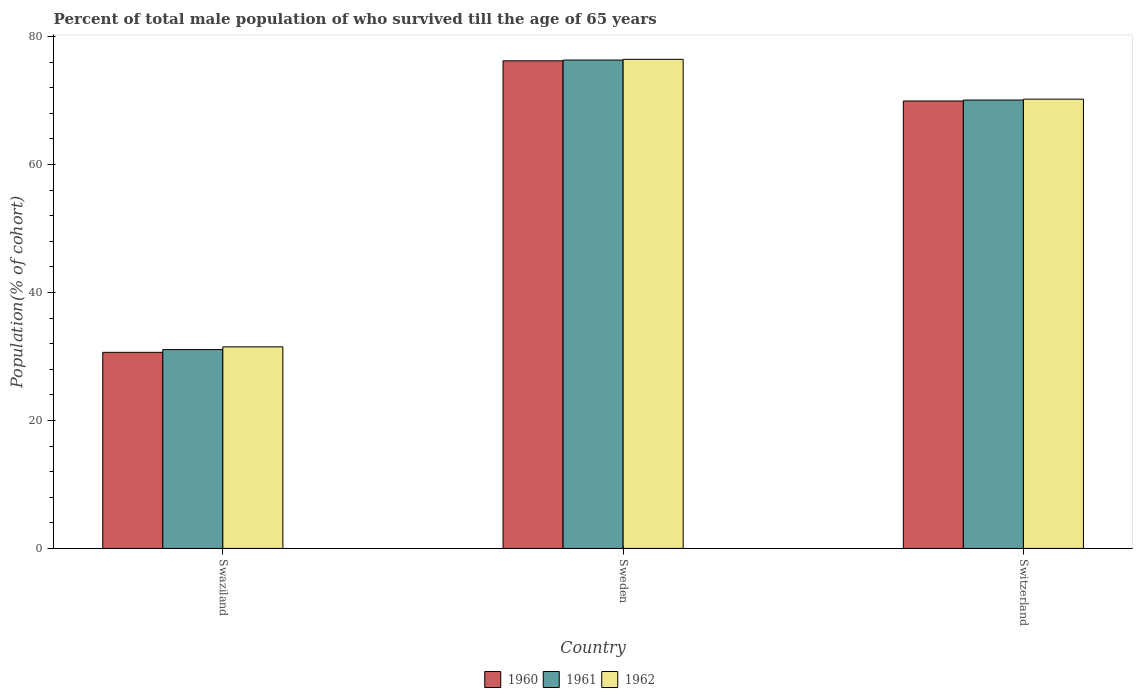How many groups of bars are there?
Your response must be concise. 3. Are the number of bars per tick equal to the number of legend labels?
Offer a terse response. Yes. What is the label of the 1st group of bars from the left?
Provide a short and direct response. Swaziland. What is the percentage of total male population who survived till the age of 65 years in 1961 in Swaziland?
Your response must be concise. 31.08. Across all countries, what is the maximum percentage of total male population who survived till the age of 65 years in 1961?
Offer a very short reply. 76.33. Across all countries, what is the minimum percentage of total male population who survived till the age of 65 years in 1961?
Offer a terse response. 31.08. In which country was the percentage of total male population who survived till the age of 65 years in 1962 minimum?
Make the answer very short. Swaziland. What is the total percentage of total male population who survived till the age of 65 years in 1960 in the graph?
Your answer should be very brief. 176.81. What is the difference between the percentage of total male population who survived till the age of 65 years in 1960 in Swaziland and that in Sweden?
Offer a very short reply. -45.56. What is the difference between the percentage of total male population who survived till the age of 65 years in 1960 in Switzerland and the percentage of total male population who survived till the age of 65 years in 1961 in Swaziland?
Your answer should be very brief. 38.86. What is the average percentage of total male population who survived till the age of 65 years in 1961 per country?
Offer a very short reply. 59.16. What is the difference between the percentage of total male population who survived till the age of 65 years of/in 1962 and percentage of total male population who survived till the age of 65 years of/in 1960 in Switzerland?
Give a very brief answer. 0.29. What is the ratio of the percentage of total male population who survived till the age of 65 years in 1960 in Swaziland to that in Sweden?
Give a very brief answer. 0.4. Is the percentage of total male population who survived till the age of 65 years in 1962 in Swaziland less than that in Switzerland?
Make the answer very short. Yes. Is the difference between the percentage of total male population who survived till the age of 65 years in 1962 in Swaziland and Switzerland greater than the difference between the percentage of total male population who survived till the age of 65 years in 1960 in Swaziland and Switzerland?
Provide a short and direct response. Yes. What is the difference between the highest and the second highest percentage of total male population who survived till the age of 65 years in 1961?
Ensure brevity in your answer.  6.25. What is the difference between the highest and the lowest percentage of total male population who survived till the age of 65 years in 1962?
Keep it short and to the point. 44.94. In how many countries, is the percentage of total male population who survived till the age of 65 years in 1961 greater than the average percentage of total male population who survived till the age of 65 years in 1961 taken over all countries?
Offer a terse response. 2. Is it the case that in every country, the sum of the percentage of total male population who survived till the age of 65 years in 1961 and percentage of total male population who survived till the age of 65 years in 1962 is greater than the percentage of total male population who survived till the age of 65 years in 1960?
Your answer should be very brief. Yes. How many bars are there?
Keep it short and to the point. 9. Are all the bars in the graph horizontal?
Make the answer very short. No. Does the graph contain any zero values?
Give a very brief answer. No. How many legend labels are there?
Provide a succinct answer. 3. How are the legend labels stacked?
Keep it short and to the point. Horizontal. What is the title of the graph?
Make the answer very short. Percent of total male population of who survived till the age of 65 years. Does "1973" appear as one of the legend labels in the graph?
Provide a succinct answer. No. What is the label or title of the X-axis?
Keep it short and to the point. Country. What is the label or title of the Y-axis?
Offer a terse response. Population(% of cohort). What is the Population(% of cohort) in 1960 in Swaziland?
Make the answer very short. 30.65. What is the Population(% of cohort) of 1961 in Swaziland?
Your answer should be compact. 31.08. What is the Population(% of cohort) of 1962 in Swaziland?
Offer a terse response. 31.51. What is the Population(% of cohort) in 1960 in Sweden?
Your response must be concise. 76.22. What is the Population(% of cohort) in 1961 in Sweden?
Keep it short and to the point. 76.33. What is the Population(% of cohort) of 1962 in Sweden?
Offer a terse response. 76.45. What is the Population(% of cohort) of 1960 in Switzerland?
Your response must be concise. 69.94. What is the Population(% of cohort) of 1961 in Switzerland?
Offer a very short reply. 70.08. What is the Population(% of cohort) of 1962 in Switzerland?
Offer a terse response. 70.22. Across all countries, what is the maximum Population(% of cohort) in 1960?
Ensure brevity in your answer.  76.22. Across all countries, what is the maximum Population(% of cohort) in 1961?
Provide a succinct answer. 76.33. Across all countries, what is the maximum Population(% of cohort) of 1962?
Your response must be concise. 76.45. Across all countries, what is the minimum Population(% of cohort) of 1960?
Provide a succinct answer. 30.65. Across all countries, what is the minimum Population(% of cohort) in 1961?
Provide a succinct answer. 31.08. Across all countries, what is the minimum Population(% of cohort) of 1962?
Your answer should be very brief. 31.51. What is the total Population(% of cohort) of 1960 in the graph?
Offer a very short reply. 176.81. What is the total Population(% of cohort) in 1961 in the graph?
Offer a very short reply. 177.49. What is the total Population(% of cohort) in 1962 in the graph?
Offer a very short reply. 178.18. What is the difference between the Population(% of cohort) of 1960 in Swaziland and that in Sweden?
Provide a succinct answer. -45.56. What is the difference between the Population(% of cohort) of 1961 in Swaziland and that in Sweden?
Make the answer very short. -45.25. What is the difference between the Population(% of cohort) of 1962 in Swaziland and that in Sweden?
Ensure brevity in your answer.  -44.94. What is the difference between the Population(% of cohort) in 1960 in Swaziland and that in Switzerland?
Provide a succinct answer. -39.28. What is the difference between the Population(% of cohort) of 1961 in Swaziland and that in Switzerland?
Ensure brevity in your answer.  -39. What is the difference between the Population(% of cohort) in 1962 in Swaziland and that in Switzerland?
Your response must be concise. -38.72. What is the difference between the Population(% of cohort) in 1960 in Sweden and that in Switzerland?
Keep it short and to the point. 6.28. What is the difference between the Population(% of cohort) in 1961 in Sweden and that in Switzerland?
Keep it short and to the point. 6.25. What is the difference between the Population(% of cohort) in 1962 in Sweden and that in Switzerland?
Offer a very short reply. 6.22. What is the difference between the Population(% of cohort) in 1960 in Swaziland and the Population(% of cohort) in 1961 in Sweden?
Provide a short and direct response. -45.68. What is the difference between the Population(% of cohort) of 1960 in Swaziland and the Population(% of cohort) of 1962 in Sweden?
Provide a short and direct response. -45.79. What is the difference between the Population(% of cohort) in 1961 in Swaziland and the Population(% of cohort) in 1962 in Sweden?
Make the answer very short. -45.37. What is the difference between the Population(% of cohort) in 1960 in Swaziland and the Population(% of cohort) in 1961 in Switzerland?
Provide a succinct answer. -39.43. What is the difference between the Population(% of cohort) of 1960 in Swaziland and the Population(% of cohort) of 1962 in Switzerland?
Ensure brevity in your answer.  -39.57. What is the difference between the Population(% of cohort) in 1961 in Swaziland and the Population(% of cohort) in 1962 in Switzerland?
Offer a very short reply. -39.14. What is the difference between the Population(% of cohort) of 1960 in Sweden and the Population(% of cohort) of 1961 in Switzerland?
Keep it short and to the point. 6.14. What is the difference between the Population(% of cohort) of 1960 in Sweden and the Population(% of cohort) of 1962 in Switzerland?
Your response must be concise. 5.99. What is the difference between the Population(% of cohort) in 1961 in Sweden and the Population(% of cohort) in 1962 in Switzerland?
Your answer should be compact. 6.11. What is the average Population(% of cohort) of 1960 per country?
Provide a short and direct response. 58.94. What is the average Population(% of cohort) in 1961 per country?
Provide a short and direct response. 59.16. What is the average Population(% of cohort) of 1962 per country?
Offer a terse response. 59.39. What is the difference between the Population(% of cohort) in 1960 and Population(% of cohort) in 1961 in Swaziland?
Provide a succinct answer. -0.43. What is the difference between the Population(% of cohort) in 1960 and Population(% of cohort) in 1962 in Swaziland?
Your answer should be compact. -0.86. What is the difference between the Population(% of cohort) in 1961 and Population(% of cohort) in 1962 in Swaziland?
Your answer should be compact. -0.43. What is the difference between the Population(% of cohort) in 1960 and Population(% of cohort) in 1961 in Sweden?
Give a very brief answer. -0.12. What is the difference between the Population(% of cohort) of 1960 and Population(% of cohort) of 1962 in Sweden?
Your answer should be compact. -0.23. What is the difference between the Population(% of cohort) in 1961 and Population(% of cohort) in 1962 in Sweden?
Offer a very short reply. -0.12. What is the difference between the Population(% of cohort) of 1960 and Population(% of cohort) of 1961 in Switzerland?
Keep it short and to the point. -0.14. What is the difference between the Population(% of cohort) of 1960 and Population(% of cohort) of 1962 in Switzerland?
Give a very brief answer. -0.29. What is the difference between the Population(% of cohort) of 1961 and Population(% of cohort) of 1962 in Switzerland?
Your answer should be very brief. -0.14. What is the ratio of the Population(% of cohort) of 1960 in Swaziland to that in Sweden?
Provide a succinct answer. 0.4. What is the ratio of the Population(% of cohort) in 1961 in Swaziland to that in Sweden?
Your answer should be compact. 0.41. What is the ratio of the Population(% of cohort) of 1962 in Swaziland to that in Sweden?
Provide a succinct answer. 0.41. What is the ratio of the Population(% of cohort) in 1960 in Swaziland to that in Switzerland?
Keep it short and to the point. 0.44. What is the ratio of the Population(% of cohort) in 1961 in Swaziland to that in Switzerland?
Give a very brief answer. 0.44. What is the ratio of the Population(% of cohort) in 1962 in Swaziland to that in Switzerland?
Offer a terse response. 0.45. What is the ratio of the Population(% of cohort) in 1960 in Sweden to that in Switzerland?
Keep it short and to the point. 1.09. What is the ratio of the Population(% of cohort) of 1961 in Sweden to that in Switzerland?
Ensure brevity in your answer.  1.09. What is the ratio of the Population(% of cohort) of 1962 in Sweden to that in Switzerland?
Your response must be concise. 1.09. What is the difference between the highest and the second highest Population(% of cohort) in 1960?
Offer a terse response. 6.28. What is the difference between the highest and the second highest Population(% of cohort) in 1961?
Offer a terse response. 6.25. What is the difference between the highest and the second highest Population(% of cohort) of 1962?
Provide a short and direct response. 6.22. What is the difference between the highest and the lowest Population(% of cohort) in 1960?
Offer a terse response. 45.56. What is the difference between the highest and the lowest Population(% of cohort) of 1961?
Ensure brevity in your answer.  45.25. What is the difference between the highest and the lowest Population(% of cohort) of 1962?
Provide a succinct answer. 44.94. 